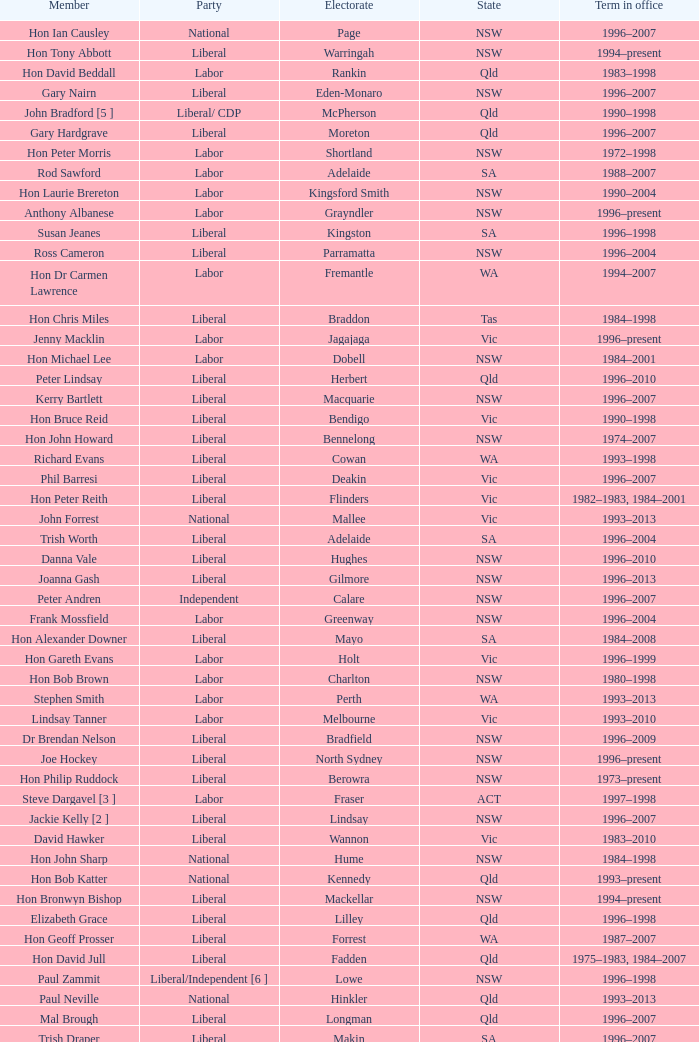Could you parse the entire table? {'header': ['Member', 'Party', 'Electorate', 'State', 'Term in office'], 'rows': [['Hon Ian Causley', 'National', 'Page', 'NSW', '1996–2007'], ['Hon Tony Abbott', 'Liberal', 'Warringah', 'NSW', '1994–present'], ['Hon David Beddall', 'Labor', 'Rankin', 'Qld', '1983–1998'], ['Gary Nairn', 'Liberal', 'Eden-Monaro', 'NSW', '1996–2007'], ['John Bradford [5 ]', 'Liberal/ CDP', 'McPherson', 'Qld', '1990–1998'], ['Gary Hardgrave', 'Liberal', 'Moreton', 'Qld', '1996–2007'], ['Hon Peter Morris', 'Labor', 'Shortland', 'NSW', '1972–1998'], ['Rod Sawford', 'Labor', 'Adelaide', 'SA', '1988–2007'], ['Hon Laurie Brereton', 'Labor', 'Kingsford Smith', 'NSW', '1990–2004'], ['Anthony Albanese', 'Labor', 'Grayndler', 'NSW', '1996–present'], ['Susan Jeanes', 'Liberal', 'Kingston', 'SA', '1996–1998'], ['Ross Cameron', 'Liberal', 'Parramatta', 'NSW', '1996–2004'], ['Hon Dr Carmen Lawrence', 'Labor', 'Fremantle', 'WA', '1994–2007'], ['Hon Chris Miles', 'Liberal', 'Braddon', 'Tas', '1984–1998'], ['Jenny Macklin', 'Labor', 'Jagajaga', 'Vic', '1996–present'], ['Hon Michael Lee', 'Labor', 'Dobell', 'NSW', '1984–2001'], ['Peter Lindsay', 'Liberal', 'Herbert', 'Qld', '1996–2010'], ['Kerry Bartlett', 'Liberal', 'Macquarie', 'NSW', '1996–2007'], ['Hon Bruce Reid', 'Liberal', 'Bendigo', 'Vic', '1990–1998'], ['Hon John Howard', 'Liberal', 'Bennelong', 'NSW', '1974–2007'], ['Richard Evans', 'Liberal', 'Cowan', 'WA', '1993–1998'], ['Phil Barresi', 'Liberal', 'Deakin', 'Vic', '1996–2007'], ['Hon Peter Reith', 'Liberal', 'Flinders', 'Vic', '1982–1983, 1984–2001'], ['John Forrest', 'National', 'Mallee', 'Vic', '1993–2013'], ['Trish Worth', 'Liberal', 'Adelaide', 'SA', '1996–2004'], ['Danna Vale', 'Liberal', 'Hughes', 'NSW', '1996–2010'], ['Joanna Gash', 'Liberal', 'Gilmore', 'NSW', '1996–2013'], ['Peter Andren', 'Independent', 'Calare', 'NSW', '1996–2007'], ['Frank Mossfield', 'Labor', 'Greenway', 'NSW', '1996–2004'], ['Hon Alexander Downer', 'Liberal', 'Mayo', 'SA', '1984–2008'], ['Hon Gareth Evans', 'Labor', 'Holt', 'Vic', '1996–1999'], ['Hon Bob Brown', 'Labor', 'Charlton', 'NSW', '1980–1998'], ['Stephen Smith', 'Labor', 'Perth', 'WA', '1993–2013'], ['Lindsay Tanner', 'Labor', 'Melbourne', 'Vic', '1993–2010'], ['Dr Brendan Nelson', 'Liberal', 'Bradfield', 'NSW', '1996–2009'], ['Joe Hockey', 'Liberal', 'North Sydney', 'NSW', '1996–present'], ['Hon Philip Ruddock', 'Liberal', 'Berowra', 'NSW', '1973–present'], ['Steve Dargavel [3 ]', 'Labor', 'Fraser', 'ACT', '1997–1998'], ['Jackie Kelly [2 ]', 'Liberal', 'Lindsay', 'NSW', '1996–2007'], ['David Hawker', 'Liberal', 'Wannon', 'Vic', '1983–2010'], ['Hon John Sharp', 'National', 'Hume', 'NSW', '1984–1998'], ['Hon Bob Katter', 'National', 'Kennedy', 'Qld', '1993–present'], ['Hon Bronwyn Bishop', 'Liberal', 'Mackellar', 'NSW', '1994–present'], ['Elizabeth Grace', 'Liberal', 'Lilley', 'Qld', '1996–1998'], ['Hon Geoff Prosser', 'Liberal', 'Forrest', 'WA', '1987–2007'], ['Hon David Jull', 'Liberal', 'Fadden', 'Qld', '1975–1983, 1984–2007'], ['Paul Zammit', 'Liberal/Independent [6 ]', 'Lowe', 'NSW', '1996–1998'], ['Paul Neville', 'National', 'Hinkler', 'Qld', '1993–2013'], ['Mal Brough', 'Liberal', 'Longman', 'Qld', '1996–2007'], ['Trish Draper', 'Liberal', 'Makin', 'SA', '1996–2007'], ['Hon Janice Crosio', 'Labor', 'Prospect', 'NSW', '1990–2004'], ['Dr Andrew Southcott', 'Liberal', 'Boothby', 'SA', '1996–present'], ['Bob Halverson', 'Liberal', 'Casey', 'Vic', '1984–1998'], ['Greg Wilton', 'Labor', 'Isaacs', 'Vic', '1996–2000'], ['Ted Grace', 'Labor', 'Fowler', 'NSW', '1984–1998'], ['Nick Dondas', 'CLP', 'Northern Territory', 'NT', '1996–1998'], ['Joel Fitzgibbon', 'Labor', 'Hunter', 'NSW', '1996–present'], ["Gavan O'Connor", 'Labor', 'Corio', 'Vic', '1993–2007'], ['Robert McClelland', 'Labor', 'Barton', 'NSW', '1996–2013'], ['Warren Entsch', 'Liberal', 'Leichhardt', 'Qld', '1996–2007, 2010–present'], ['Hon Andrew Thomson', 'Liberal', 'Wentworth', 'NSW', '1995–2001'], ['Pauline Hanson [4 ]', 'Independent/ ONP', 'Oxley', 'Qld', '1996–1998'], ['Hon Arch Bevis', 'Labor', 'Brisbane', 'Qld', '1990–2010'], ['Jim Lloyd', 'Liberal', 'Robertson', 'NSW', '1996–2007'], ['Hon Duncan Kerr', 'Labor', 'Denison', 'Tas', '1987–2010'], ['Kay Elson', 'Liberal', 'Forde', 'Qld', '1996–2007'], ['Harry Jenkins', 'Labor', 'Scullin', 'Vic', '1986–2013'], ['Martin Ferguson', 'Labor', 'Batman', 'Vic', '1996–2013'], ['Paul Marek', 'National', 'Capricornia', 'Qld', '1996–1998'], ['Paul Keating [1 ]', 'Labor', 'Blaxland', 'NSW', '1969–1996'], ['Allan Rocher', 'Independent', 'Curtin', 'WA', '1981–1998'], ['Hon Bob McMullan', 'Labor', 'Canberra', 'ACT', '1996–2010'], ['Bruce Billson', 'Liberal', 'Dunkley', 'Vic', '1996–present'], ['Bill Taylor', 'Liberal', 'Groom', 'Qld', '1988–1998'], ['Hon John Anderson', 'National', 'Gwydir', 'NSW', '1989–2007'], ['Christopher Pyne', 'Liberal', 'Sturt', 'SA', '1993–present'], ['Dr Sharman Stone', 'Liberal', 'Murray', 'Vic', '1996–present'], ['Mark Vaile', 'National', 'Lyne', 'NSW', '1993–2008'], ['Hon Lou Lieberman', 'Liberal', 'Indi', 'Vic', '1993–2001'], ['Colin Hollis', 'Labor', 'Throsby', 'NSW', '1984–2001'], ['Warren Truss', 'National', 'Wide Bay', 'Qld', '1990–present'], ['Kathy Sullivan', 'Liberal', 'Moncrieff', 'Qld', '1984–2001'], ['Russell Broadbent', 'Liberal', 'McMillan', 'Vic', '1990–1993, 1996–1998 2004–present'], ['John Langmore [3 ]', 'Labor', 'Fraser', 'ACT', '1984–1997'], ['Petro Georgiou', 'Liberal', 'Kooyong', 'Vic', '1994–2010'], ['Bob Charles', 'Liberal', 'La Trobe', 'Vic', '1990–2004'], ['Hon Kim Beazley', 'Labor', 'Brand', 'WA', '1980–2007'], ['Harry Quick', 'Labor', 'Franklin', 'Tas', '1993–2007'], ['Hon Dr David Kemp', 'Liberal', 'Goldstein', 'Vic', '1990–2004'], ['Larry Anthony', 'National', 'Richmond', 'NSW', '1996–2004'], ['Alex Somlyay', 'Liberal', 'Fairfax', 'Qld', '1990–2013'], ['Peter Slipper', 'Liberal', 'Fisher', 'Qld', '1984–1987, 1993–2013'], ['Fran Bailey', 'Liberal', 'McEwen', 'Vic', '1990–1993, 1996–2010'], ['Hon Daryl Williams', 'Liberal', 'Tangney', 'WA', '1993–2004'], ['Neil Andrew', 'Liberal', 'Wakefield', 'SA', '1983–2004'], ['Andrea West', 'Liberal', 'Bowman', 'Qld', '1996–1998'], ['Bob Sercombe', 'Labor', 'Maribyrnong', 'Vic', '1996–2007'], ['Hon Clyde Holding', 'Labor', 'Melbourne Ports', 'Vic', '1977–1998'], ['Noel Hicks', 'National', 'Riverina', 'NSW', '1980–1998'], ['Hon Michael Wooldridge', 'Liberal', 'Casey', 'Vic', '1987–2001'], ['Bob Baldwin', 'Liberal', 'Paterson', 'NSW', '1996–present'], ['Hon Ralph Willis', 'Labor', 'Gellibrand', 'Vic', '1972–1998'], ['John Fahey', 'Liberal', 'Macarthur', 'NSW', '1996–2001'], ['Paul Filing', 'Independent', 'Moore', 'WA', '1990–1998'], ['Laurie Ferguson', 'Labor', 'Reid', 'NSW', '1990–present'], ['Ricky Johnston', 'Liberal', 'Canning', 'WA', '1996–1998'], ['Hon Judi Moylan', 'Liberal', 'Pearce', 'WA', '1993–2013'], ['Allan Morris', 'Labor', 'Newcastle', 'NSW', '1983–2001'], ['Hon Martyn Evans', 'Labor', 'Bonython', 'SA', '1994–2004'], ['Kevin Andrews', 'Liberal', 'Menzies', 'Vic', '1991–present'], ['Peter Nugent', 'Liberal', 'Aston', 'Vic', '1990–2001'], ['Graeme McDougall', 'Liberal', 'Griffith', 'Qld', '1996–1998'], ['Stephen Mutch', 'Liberal', 'Cook', 'NSW', '1996–1998'], ['Barry Wakelin', 'Liberal', 'Grey', 'SA', '1993–2007'], ['Hon Dick Adams', 'Labor', 'Lyons', 'Tas', '1993–2013'], ['Michael Hatton [1 ]', 'Labor', 'Blaxland', 'NSW', '1996–2007'], ['Hon Andrew Theophanous', 'Labor', 'Calwell', 'Vic', '1980–2001'], ['Teresa Gambaro', 'Liberal', 'Petrie', 'Qld', '1996–2007, 2010–present'], ['Alan Cadman', 'Liberal', 'Mitchell', 'NSW', '1974–2007'], ['Hon Barry Jones', 'Labor', 'Lalor', 'Vic', '1977–1998'], ['Hon Peter Costello', 'Liberal', 'Higgins', 'Vic', '1990–2009'], ['Tony Smith', 'Liberal/Independent [7 ]', 'Dickson', 'Qld', '1996–1998'], ['Hon Ian Sinclair', 'National', 'New England', 'NSW', '1963–1998'], ['Graeme Campbell', 'Independent', 'Kalgoorlie', 'WA', '1980–1998'], ['Michael Cobb', 'National', 'Parkes', 'NSW', '1984–1998'], ['De-Anne Kelly', 'National', 'Dawson', 'Qld', '1996–2007'], ['Don Randall', 'Liberal', 'Swan', 'WA', '1996–1998, 2001–present'], ['Hon Bruce Scott', 'National', 'Maranoa', 'Qld', '1990–present'], ['Annette Ellis', 'Labor', 'Namadgi', 'ACT', '1996–2010'], ['Hon Leo McLeay', 'Labor', 'Watson', 'NSW', '1979–2004'], ['Hon Ian McLachlan', 'Liberal', 'Barker', 'SA', '1990–1998'], ['Kelvin Thomson', 'Labor', 'Wills', 'Vic', '1996–present'], ['Hon Simon Crean', 'Labor', 'Hotham', 'Vic', '1990–2013'], ['Mark Latham', 'Labor', 'Werriwa', 'NSW', '1994–2005'], ["Hon Neil O'Keefe", 'Labor', 'Burke', 'Vic', '1984–2001'], ['Hon Peter Baldwin', 'Labor', 'Sydney', 'NSW', '1983–1998'], ['Wilson Tuckey', 'Liberal', "O'Connor", 'WA', '1980–2010'], ['Garry Nehl', 'National', 'Cowper', 'NSW', '1984–2001'], ['Alan Griffin', 'Labor', 'Bruce', 'Vic', '1993–present'], ['Daryl Melham', 'Labor', 'Banks', 'NSW', '1990–2013'], ['Hon Warwick Smith', 'Liberal', 'Bass', 'Tas', '1984–1993, 1996–1998'], ['Christine Gallus', 'Liberal', 'Hindmarsh', 'SA', '1990–2004'], ['Hon Peter McGauran', 'National', 'Gippsland', 'Vic', '1983–2008'], ['Eoin Cameron', 'Liberal', 'Stirling', 'WA', '1993–1998'], ['Stewart McArthur', 'Liberal', 'Corangamite', 'Vic', '1984–2007'], ['Michael Ronaldson', 'Liberal', 'Ballarat', 'Vic', '1990–2001'], ['Hon Stephen Martin', 'Labor', 'Cunningham', 'NSW', '1984–2002'], ['Hon Roger Price', 'Labor', 'Chifley', 'NSW', '1984–2010'], ['Hon John Moore', 'Liberal', 'Ryan', 'Qld', '1975–2001'], ['Hon Tim Fischer', 'National', 'Farrer', 'NSW', '1984–2001']]} In what state was the electorate fowler? NSW. 